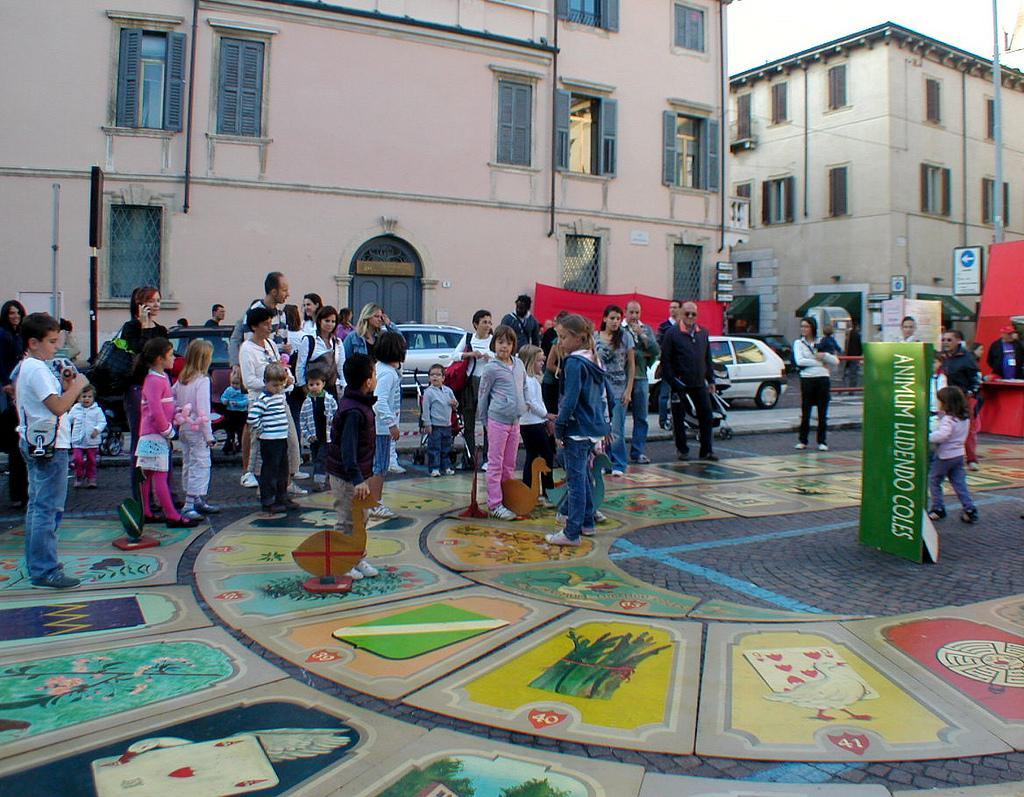In one or two sentences, can you explain what this image depicts? In this image I can see the group of people standing and wearing the different color dresses. To the side of these people there are banners and the vehicles. To the side of these vehicles there are buildings and there are windows to it. In the background there is a sky. 